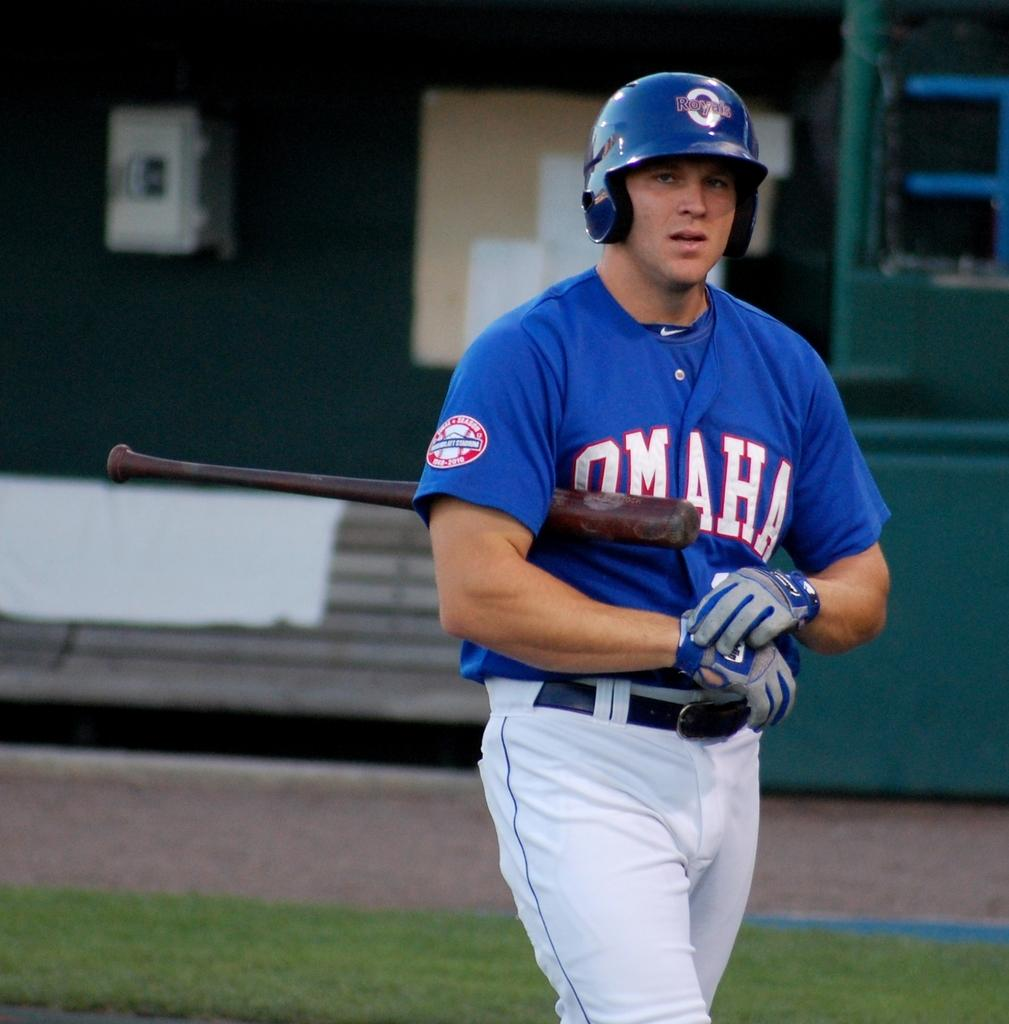<image>
Write a terse but informative summary of the picture. A baseball player wearing a blue Omaha tee shirt with a baseball helmet emblazoned with Royals. 